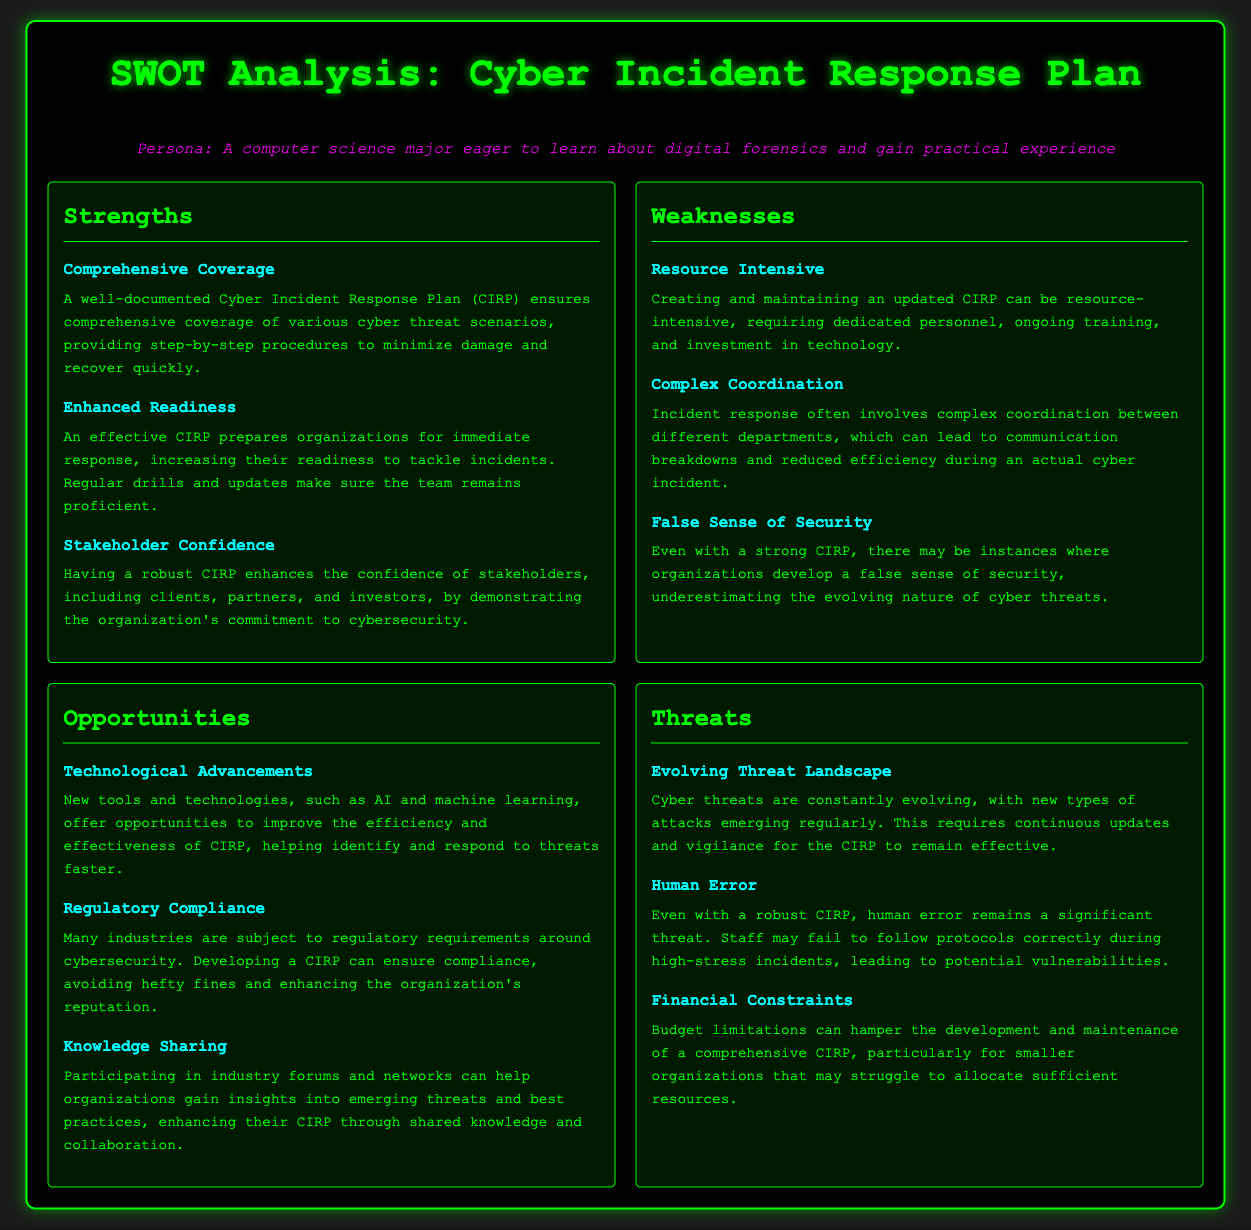What are the strengths listed in the SWOT analysis? The strengths are identified under the “Strengths” section and include Comprehensive Coverage, Enhanced Readiness, and Stakeholder Confidence.
Answer: Comprehensive Coverage, Enhanced Readiness, Stakeholder Confidence How many weaknesses are identified in the document? The number of weaknesses can be counted from the "Weaknesses" section where three weaknesses are listed.
Answer: 3 What is one opportunity mentioned in the SWOT analysis? One example of an opportunity is found in the "Opportunities" section, which states Technological Advancements.
Answer: Technological Advancements What threat is associated with human actions in the document? The threat related to human actions can be found under the "Threats" section, which highlights Human Error.
Answer: Human Error Which section discusses stakeholder confidence? Stakeholder confidence is discussed in the "Strengths" section, emphasizing the importance of a robust CIRP.
Answer: Strengths What does CIRP stand for? The document references the acronym CIRP, which stands for Cyber Incident Response Plan.
Answer: Cyber Incident Response Plan What potential challenge is mentioned regarding resource allocation? The challenge related to resource allocation is highlighted in the "Weaknesses" section as Financial Constraints.
Answer: Financial Constraints What improves the efficiency of CIRP according to the document? The document suggests that new tools and technologies notably improve the efficiency of the CIRP under the "Opportunities" section.
Answer: AI and machine learning Which section would you refer to for emerging threats insights? The "Opportunities" section provides insights on gaining knowledge through sharing in industry forums, which is essential for understanding emerging threats.
Answer: Opportunities 